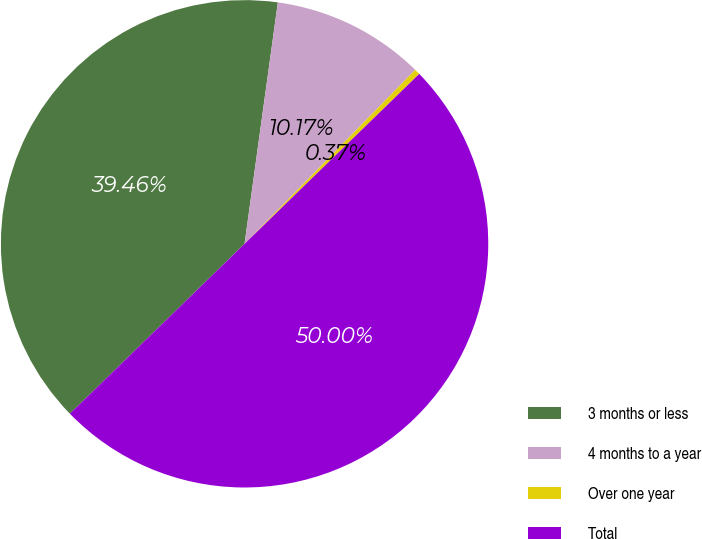Convert chart. <chart><loc_0><loc_0><loc_500><loc_500><pie_chart><fcel>3 months or less<fcel>4 months to a year<fcel>Over one year<fcel>Total<nl><fcel>39.46%<fcel>10.17%<fcel>0.37%<fcel>50.0%<nl></chart> 